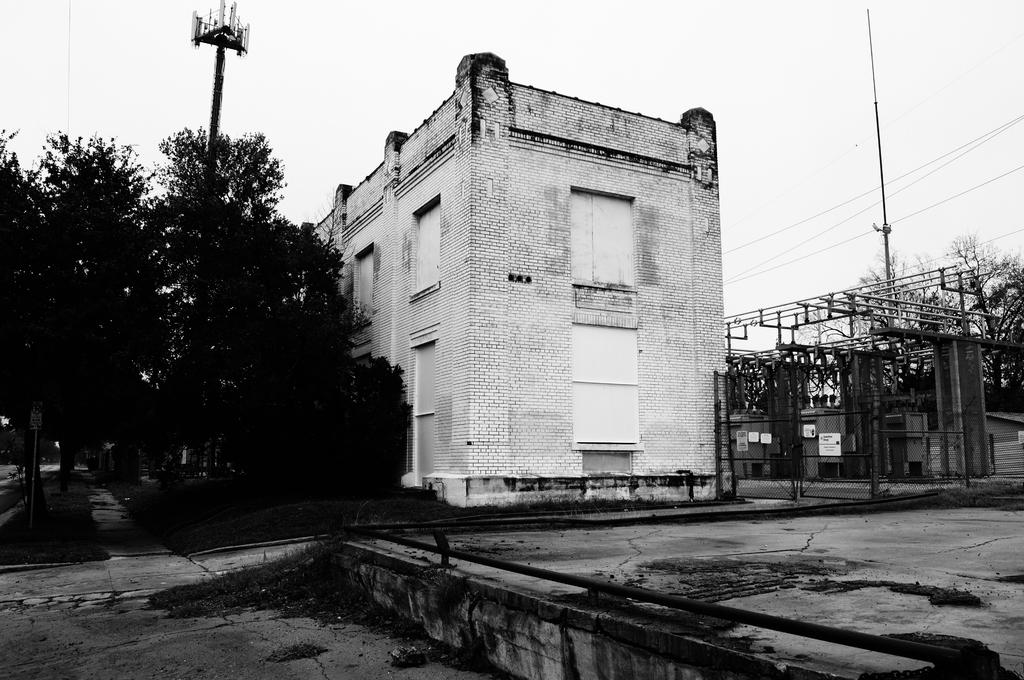What type of structure is present in the image? There is a building in the image. What other objects can be seen in the image? There are trees and poles in the image. What is the color scheme of the image? The image is black and white in color. What can be seen in the background of the image? The sky is visible in the background of the image. How many ghosts are visible in the image? There are no ghosts present in the image; it is a black and white image featuring a building, trees, poles, and the sky. 